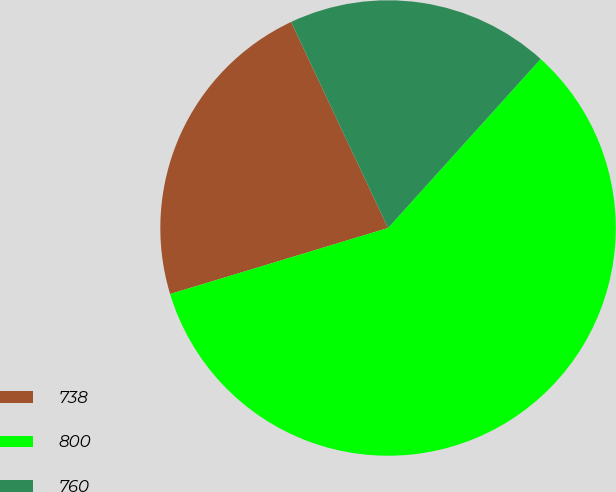Convert chart to OTSL. <chart><loc_0><loc_0><loc_500><loc_500><pie_chart><fcel>738<fcel>800<fcel>760<nl><fcel>22.68%<fcel>58.63%<fcel>18.69%<nl></chart> 